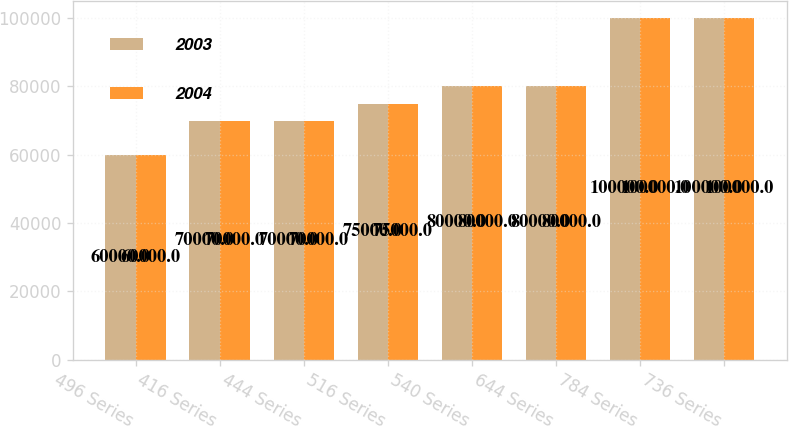Convert chart to OTSL. <chart><loc_0><loc_0><loc_500><loc_500><stacked_bar_chart><ecel><fcel>496 Series<fcel>416 Series<fcel>444 Series<fcel>516 Series<fcel>540 Series<fcel>644 Series<fcel>784 Series<fcel>736 Series<nl><fcel>2003<fcel>60000<fcel>70000<fcel>70000<fcel>75000<fcel>80000<fcel>80000<fcel>100000<fcel>100000<nl><fcel>2004<fcel>60000<fcel>70000<fcel>70000<fcel>75000<fcel>80000<fcel>80000<fcel>100000<fcel>100000<nl></chart> 